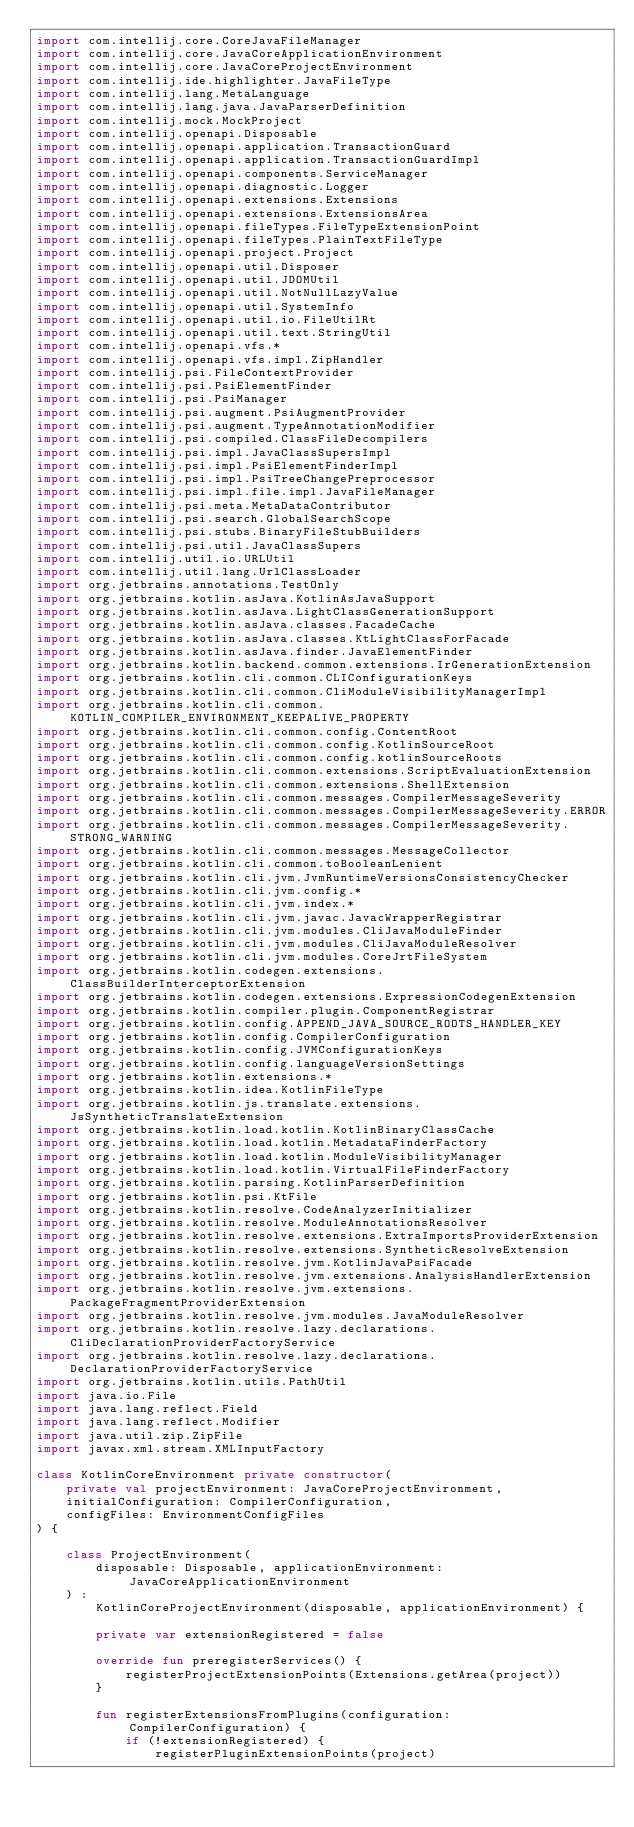Convert code to text. <code><loc_0><loc_0><loc_500><loc_500><_Kotlin_>import com.intellij.core.CoreJavaFileManager
import com.intellij.core.JavaCoreApplicationEnvironment
import com.intellij.core.JavaCoreProjectEnvironment
import com.intellij.ide.highlighter.JavaFileType
import com.intellij.lang.MetaLanguage
import com.intellij.lang.java.JavaParserDefinition
import com.intellij.mock.MockProject
import com.intellij.openapi.Disposable
import com.intellij.openapi.application.TransactionGuard
import com.intellij.openapi.application.TransactionGuardImpl
import com.intellij.openapi.components.ServiceManager
import com.intellij.openapi.diagnostic.Logger
import com.intellij.openapi.extensions.Extensions
import com.intellij.openapi.extensions.ExtensionsArea
import com.intellij.openapi.fileTypes.FileTypeExtensionPoint
import com.intellij.openapi.fileTypes.PlainTextFileType
import com.intellij.openapi.project.Project
import com.intellij.openapi.util.Disposer
import com.intellij.openapi.util.JDOMUtil
import com.intellij.openapi.util.NotNullLazyValue
import com.intellij.openapi.util.SystemInfo
import com.intellij.openapi.util.io.FileUtilRt
import com.intellij.openapi.util.text.StringUtil
import com.intellij.openapi.vfs.*
import com.intellij.openapi.vfs.impl.ZipHandler
import com.intellij.psi.FileContextProvider
import com.intellij.psi.PsiElementFinder
import com.intellij.psi.PsiManager
import com.intellij.psi.augment.PsiAugmentProvider
import com.intellij.psi.augment.TypeAnnotationModifier
import com.intellij.psi.compiled.ClassFileDecompilers
import com.intellij.psi.impl.JavaClassSupersImpl
import com.intellij.psi.impl.PsiElementFinderImpl
import com.intellij.psi.impl.PsiTreeChangePreprocessor
import com.intellij.psi.impl.file.impl.JavaFileManager
import com.intellij.psi.meta.MetaDataContributor
import com.intellij.psi.search.GlobalSearchScope
import com.intellij.psi.stubs.BinaryFileStubBuilders
import com.intellij.psi.util.JavaClassSupers
import com.intellij.util.io.URLUtil
import com.intellij.util.lang.UrlClassLoader
import org.jetbrains.annotations.TestOnly
import org.jetbrains.kotlin.asJava.KotlinAsJavaSupport
import org.jetbrains.kotlin.asJava.LightClassGenerationSupport
import org.jetbrains.kotlin.asJava.classes.FacadeCache
import org.jetbrains.kotlin.asJava.classes.KtLightClassForFacade
import org.jetbrains.kotlin.asJava.finder.JavaElementFinder
import org.jetbrains.kotlin.backend.common.extensions.IrGenerationExtension
import org.jetbrains.kotlin.cli.common.CLIConfigurationKeys
import org.jetbrains.kotlin.cli.common.CliModuleVisibilityManagerImpl
import org.jetbrains.kotlin.cli.common.KOTLIN_COMPILER_ENVIRONMENT_KEEPALIVE_PROPERTY
import org.jetbrains.kotlin.cli.common.config.ContentRoot
import org.jetbrains.kotlin.cli.common.config.KotlinSourceRoot
import org.jetbrains.kotlin.cli.common.config.kotlinSourceRoots
import org.jetbrains.kotlin.cli.common.extensions.ScriptEvaluationExtension
import org.jetbrains.kotlin.cli.common.extensions.ShellExtension
import org.jetbrains.kotlin.cli.common.messages.CompilerMessageSeverity
import org.jetbrains.kotlin.cli.common.messages.CompilerMessageSeverity.ERROR
import org.jetbrains.kotlin.cli.common.messages.CompilerMessageSeverity.STRONG_WARNING
import org.jetbrains.kotlin.cli.common.messages.MessageCollector
import org.jetbrains.kotlin.cli.common.toBooleanLenient
import org.jetbrains.kotlin.cli.jvm.JvmRuntimeVersionsConsistencyChecker
import org.jetbrains.kotlin.cli.jvm.config.*
import org.jetbrains.kotlin.cli.jvm.index.*
import org.jetbrains.kotlin.cli.jvm.javac.JavacWrapperRegistrar
import org.jetbrains.kotlin.cli.jvm.modules.CliJavaModuleFinder
import org.jetbrains.kotlin.cli.jvm.modules.CliJavaModuleResolver
import org.jetbrains.kotlin.cli.jvm.modules.CoreJrtFileSystem
import org.jetbrains.kotlin.codegen.extensions.ClassBuilderInterceptorExtension
import org.jetbrains.kotlin.codegen.extensions.ExpressionCodegenExtension
import org.jetbrains.kotlin.compiler.plugin.ComponentRegistrar
import org.jetbrains.kotlin.config.APPEND_JAVA_SOURCE_ROOTS_HANDLER_KEY
import org.jetbrains.kotlin.config.CompilerConfiguration
import org.jetbrains.kotlin.config.JVMConfigurationKeys
import org.jetbrains.kotlin.config.languageVersionSettings
import org.jetbrains.kotlin.extensions.*
import org.jetbrains.kotlin.idea.KotlinFileType
import org.jetbrains.kotlin.js.translate.extensions.JsSyntheticTranslateExtension
import org.jetbrains.kotlin.load.kotlin.KotlinBinaryClassCache
import org.jetbrains.kotlin.load.kotlin.MetadataFinderFactory
import org.jetbrains.kotlin.load.kotlin.ModuleVisibilityManager
import org.jetbrains.kotlin.load.kotlin.VirtualFileFinderFactory
import org.jetbrains.kotlin.parsing.KotlinParserDefinition
import org.jetbrains.kotlin.psi.KtFile
import org.jetbrains.kotlin.resolve.CodeAnalyzerInitializer
import org.jetbrains.kotlin.resolve.ModuleAnnotationsResolver
import org.jetbrains.kotlin.resolve.extensions.ExtraImportsProviderExtension
import org.jetbrains.kotlin.resolve.extensions.SyntheticResolveExtension
import org.jetbrains.kotlin.resolve.jvm.KotlinJavaPsiFacade
import org.jetbrains.kotlin.resolve.jvm.extensions.AnalysisHandlerExtension
import org.jetbrains.kotlin.resolve.jvm.extensions.PackageFragmentProviderExtension
import org.jetbrains.kotlin.resolve.jvm.modules.JavaModuleResolver
import org.jetbrains.kotlin.resolve.lazy.declarations.CliDeclarationProviderFactoryService
import org.jetbrains.kotlin.resolve.lazy.declarations.DeclarationProviderFactoryService
import org.jetbrains.kotlin.utils.PathUtil
import java.io.File
import java.lang.reflect.Field
import java.lang.reflect.Modifier
import java.util.zip.ZipFile
import javax.xml.stream.XMLInputFactory

class KotlinCoreEnvironment private constructor(
    private val projectEnvironment: JavaCoreProjectEnvironment,
    initialConfiguration: CompilerConfiguration,
    configFiles: EnvironmentConfigFiles
) {

    class ProjectEnvironment(
        disposable: Disposable, applicationEnvironment: JavaCoreApplicationEnvironment
    ) :
        KotlinCoreProjectEnvironment(disposable, applicationEnvironment) {

        private var extensionRegistered = false

        override fun preregisterServices() {
            registerProjectExtensionPoints(Extensions.getArea(project))
        }

        fun registerExtensionsFromPlugins(configuration: CompilerConfiguration) {
            if (!extensionRegistered) {
                registerPluginExtensionPoints(project)</code> 